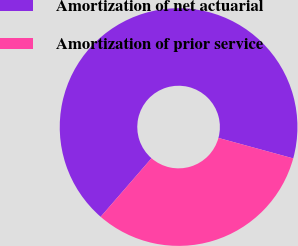Convert chart. <chart><loc_0><loc_0><loc_500><loc_500><pie_chart><fcel>Amortization of net actuarial<fcel>Amortization of prior service<nl><fcel>67.87%<fcel>32.13%<nl></chart> 